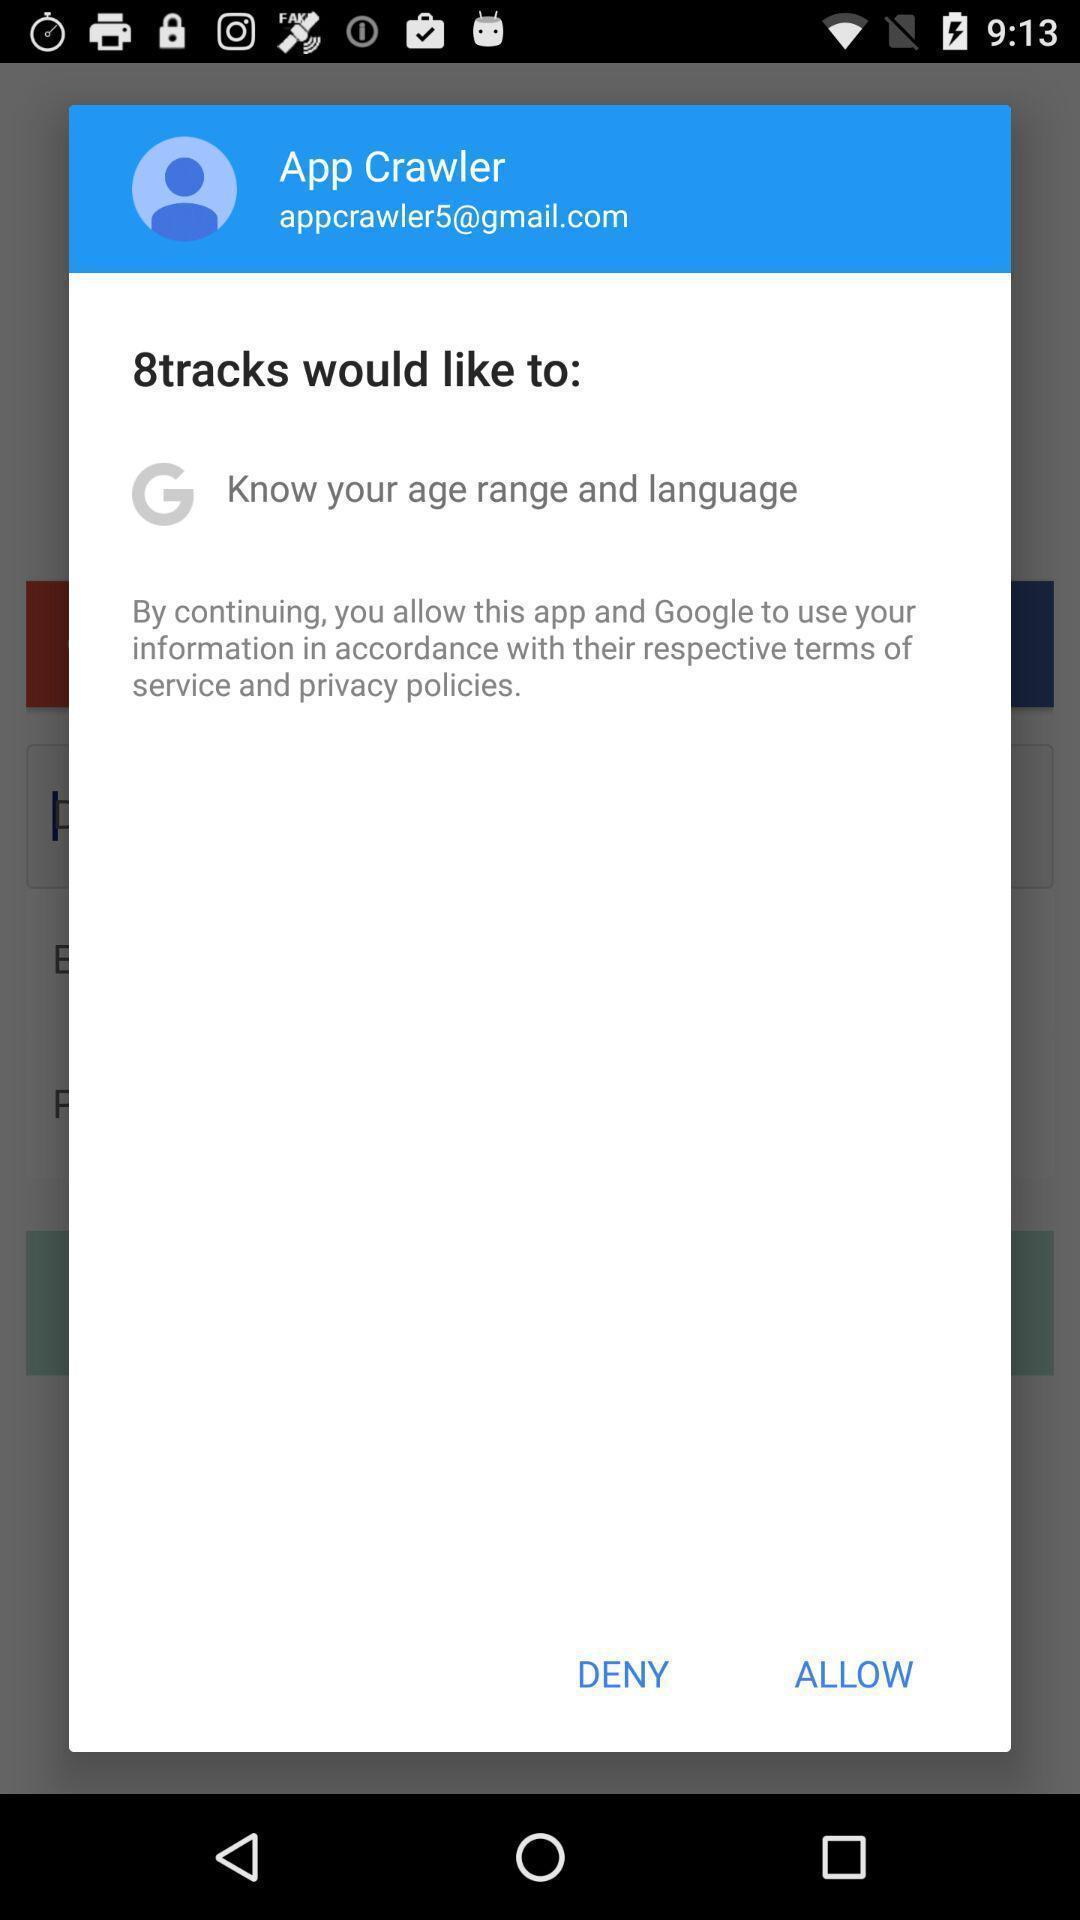Describe the visual elements of this screenshot. Profile of tracks to know. 